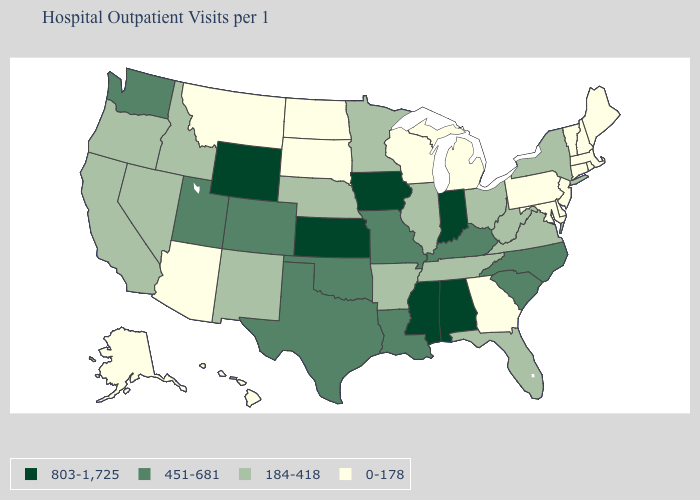What is the lowest value in the USA?
Short answer required. 0-178. Name the states that have a value in the range 451-681?
Concise answer only. Colorado, Kentucky, Louisiana, Missouri, North Carolina, Oklahoma, South Carolina, Texas, Utah, Washington. What is the value of Missouri?
Keep it brief. 451-681. What is the value of Pennsylvania?
Write a very short answer. 0-178. Name the states that have a value in the range 184-418?
Short answer required. Arkansas, California, Florida, Idaho, Illinois, Minnesota, Nebraska, Nevada, New Mexico, New York, Ohio, Oregon, Tennessee, Virginia, West Virginia. What is the highest value in states that border Florida?
Quick response, please. 803-1,725. Name the states that have a value in the range 451-681?
Short answer required. Colorado, Kentucky, Louisiana, Missouri, North Carolina, Oklahoma, South Carolina, Texas, Utah, Washington. Does Wyoming have the highest value in the West?
Write a very short answer. Yes. What is the value of Washington?
Short answer required. 451-681. What is the value of New Mexico?
Give a very brief answer. 184-418. What is the value of Wisconsin?
Short answer required. 0-178. Name the states that have a value in the range 451-681?
Answer briefly. Colorado, Kentucky, Louisiana, Missouri, North Carolina, Oklahoma, South Carolina, Texas, Utah, Washington. What is the value of Florida?
Keep it brief. 184-418. How many symbols are there in the legend?
Be succinct. 4. Does Wyoming have the highest value in the West?
Concise answer only. Yes. 